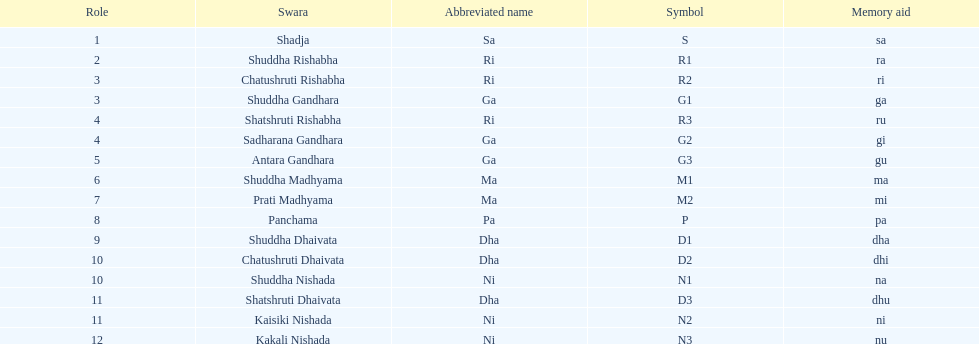What is the name of the swara that comes after panchama? Shuddha Dhaivata. 